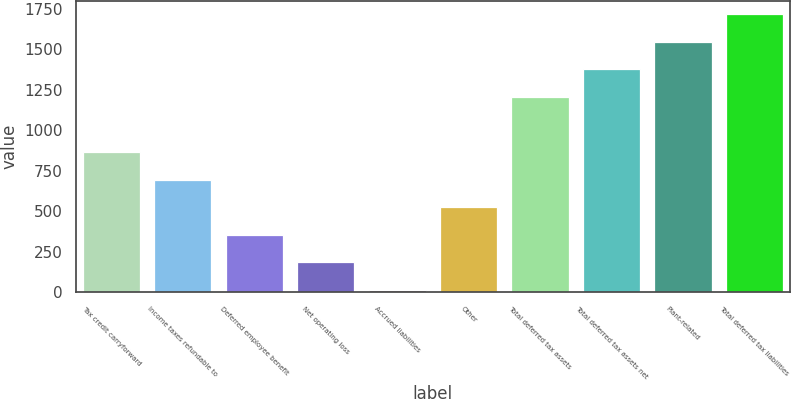Convert chart. <chart><loc_0><loc_0><loc_500><loc_500><bar_chart><fcel>Tax credit carryforward<fcel>Income taxes refundable to<fcel>Deferred employee benefit<fcel>Net operating loss<fcel>Accrued liabilities<fcel>Other<fcel>Total deferred tax assets<fcel>Total deferred tax assets net<fcel>Plant-related<fcel>Total deferred tax liabilities<nl><fcel>864.45<fcel>694.2<fcel>353.7<fcel>183.45<fcel>13.2<fcel>523.95<fcel>1204.95<fcel>1375.2<fcel>1545.45<fcel>1715.7<nl></chart> 